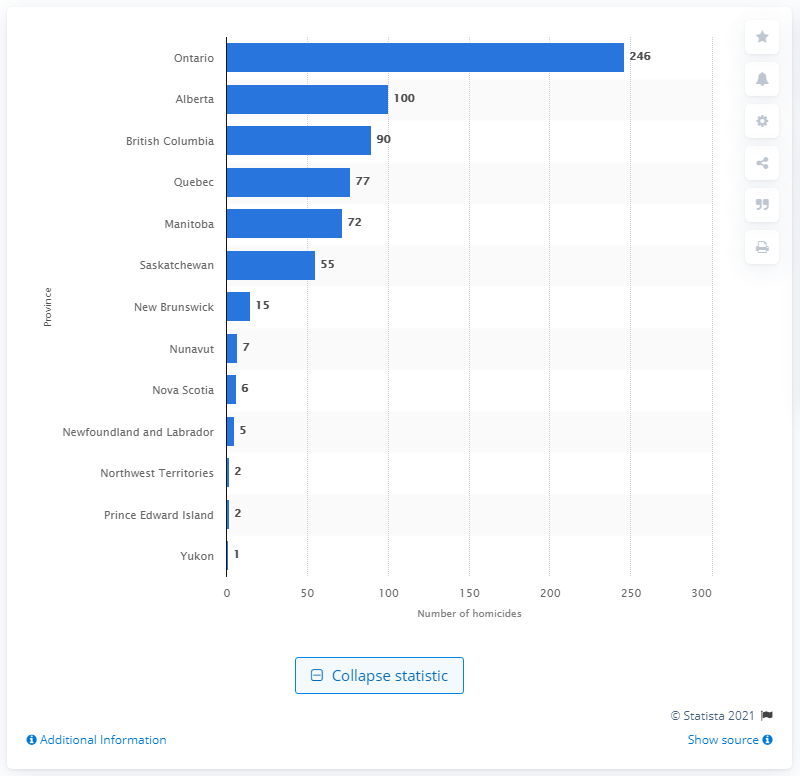Specify some key components in this picture. In 2019, a total of 246 homicides were reported in Ontario. 